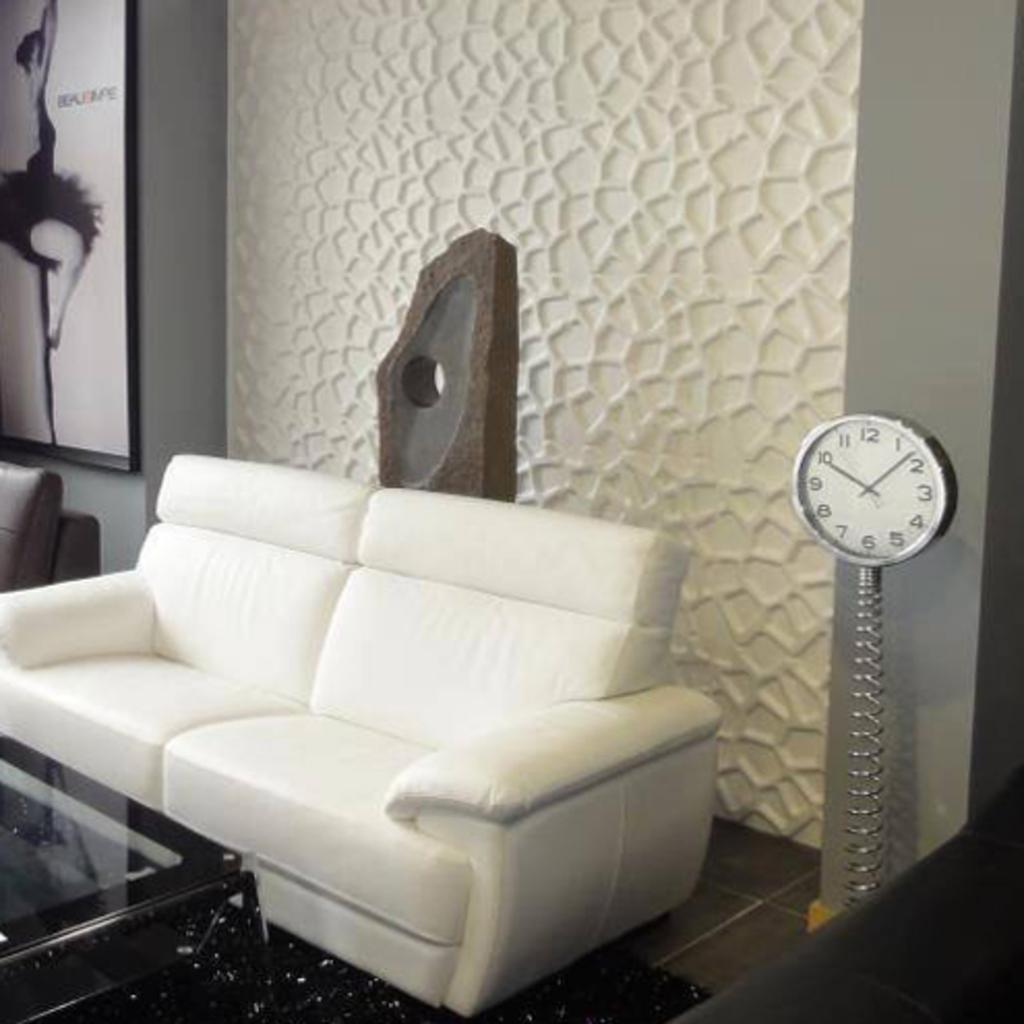Provide a one-sentence caption for the provided image. White sofa next to a clock which has the hands on the numbers 10 and 2. 